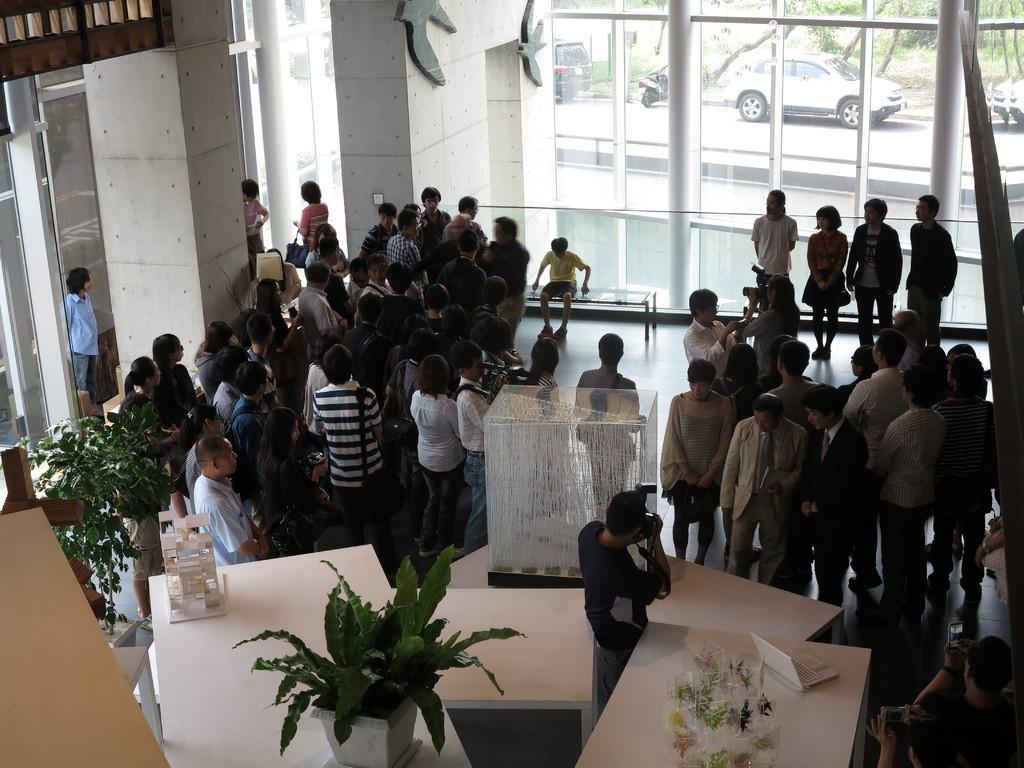Can you describe this image briefly? In this image we can see group of people. There are tables, plants, laptop, and decorative items. Here we can see pillars and glasses. Through the glass we can see trees and cars on the road. 